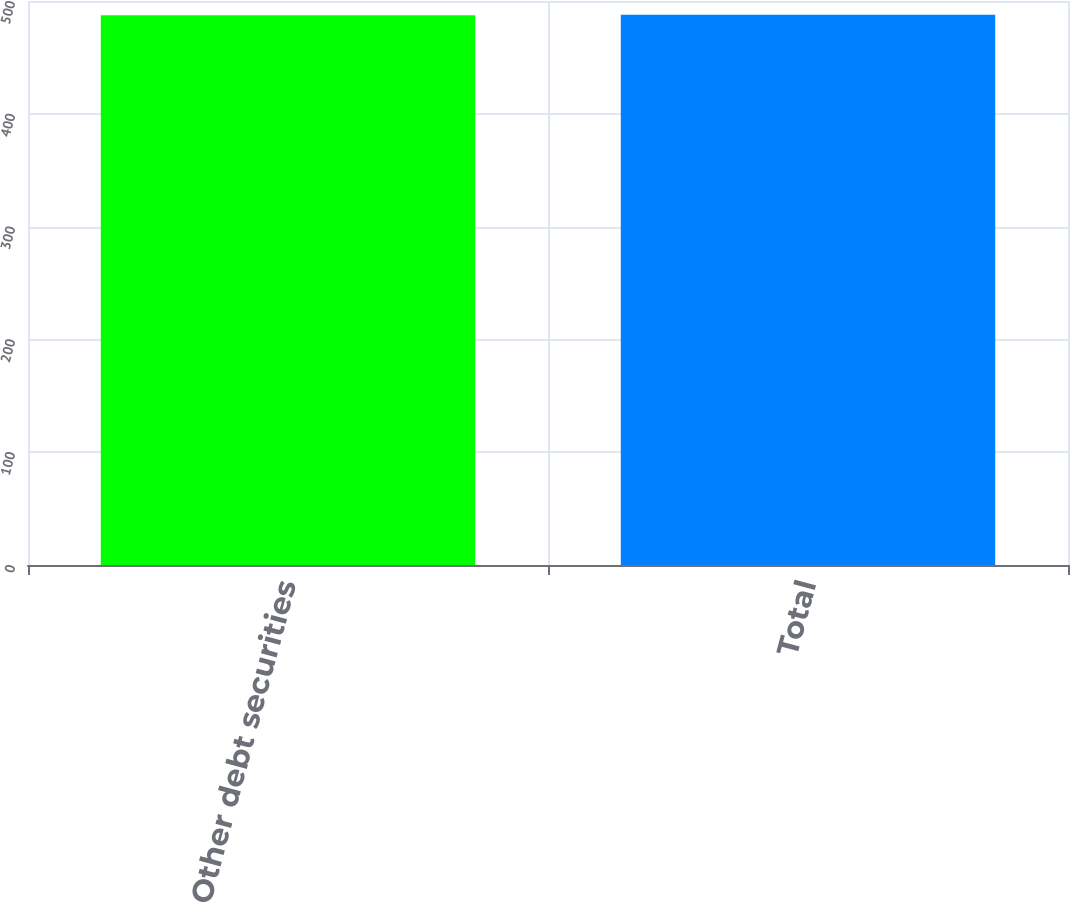Convert chart. <chart><loc_0><loc_0><loc_500><loc_500><bar_chart><fcel>Other debt securities<fcel>Total<nl><fcel>487.3<fcel>487.8<nl></chart> 